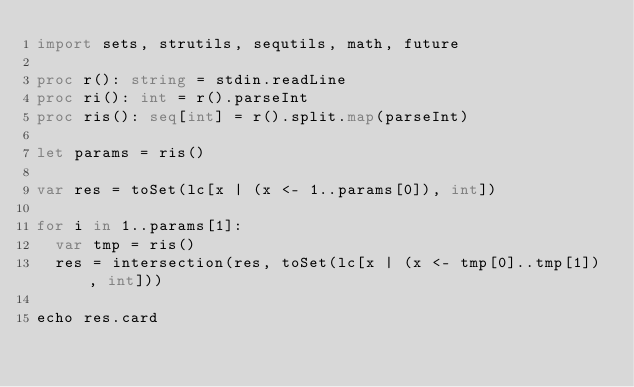Convert code to text. <code><loc_0><loc_0><loc_500><loc_500><_Nim_>import sets, strutils, sequtils, math, future

proc r(): string = stdin.readLine
proc ri(): int = r().parseInt
proc ris(): seq[int] = r().split.map(parseInt)

let params = ris()

var res = toSet(lc[x | (x <- 1..params[0]), int])

for i in 1..params[1]:
  var tmp = ris()
  res = intersection(res, toSet(lc[x | (x <- tmp[0]..tmp[1]), int]))

echo res.card</code> 